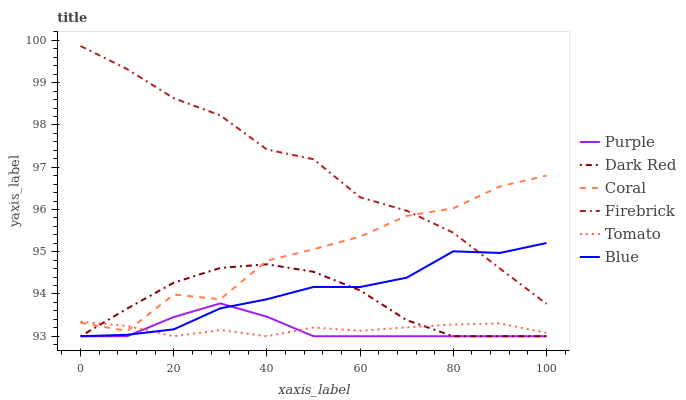Does Blue have the minimum area under the curve?
Answer yes or no. No. Does Blue have the maximum area under the curve?
Answer yes or no. No. Is Blue the smoothest?
Answer yes or no. No. Is Blue the roughest?
Answer yes or no. No. Does Coral have the lowest value?
Answer yes or no. No. Does Blue have the highest value?
Answer yes or no. No. Is Dark Red less than Firebrick?
Answer yes or no. Yes. Is Firebrick greater than Tomato?
Answer yes or no. Yes. Does Dark Red intersect Firebrick?
Answer yes or no. No. 